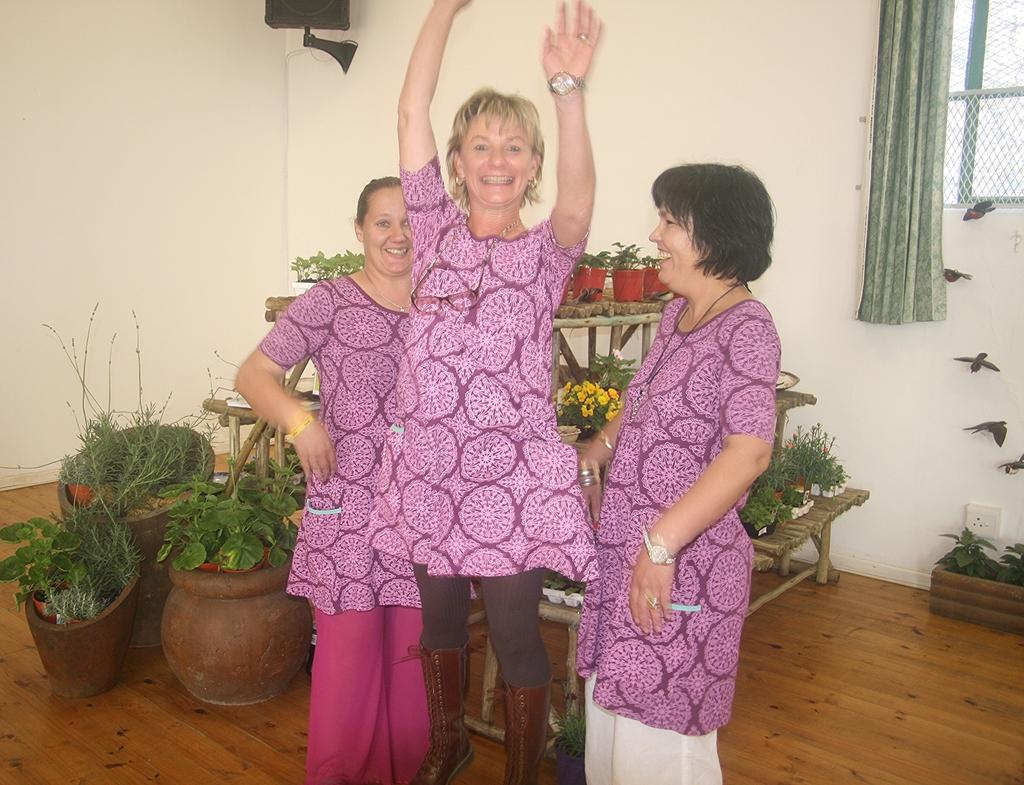How many women are in the image? There are three women in the image. What are the women doing in the image? The women are standing behind something. What type of plants can be seen in the image? There are potted plants in the image. What architectural features are present in the image? There is a window and a wall in the image. What value can be calculated using the calculator in the image? There is no calculator present in the image. What degree of difficulty is the task being performed by the women in the image? The image does not provide any information about the difficulty of the task being performed by the women. 